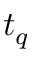<formula> <loc_0><loc_0><loc_500><loc_500>t _ { q }</formula> 